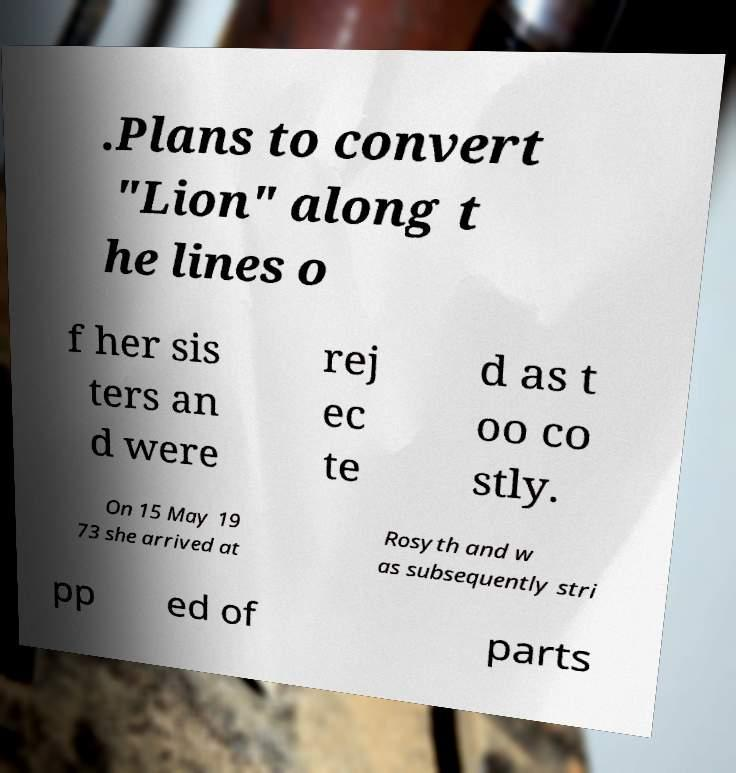Can you read and provide the text displayed in the image?This photo seems to have some interesting text. Can you extract and type it out for me? .Plans to convert "Lion" along t he lines o f her sis ters an d were rej ec te d as t oo co stly. On 15 May 19 73 she arrived at Rosyth and w as subsequently stri pp ed of parts 